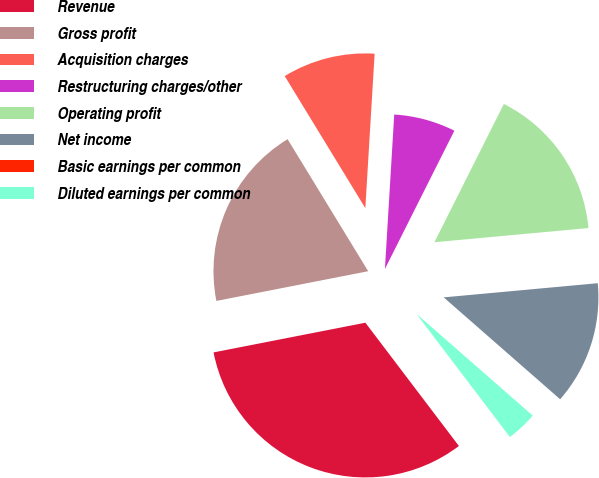Convert chart. <chart><loc_0><loc_0><loc_500><loc_500><pie_chart><fcel>Revenue � � � � � � � � � � �<fcel>Gross profit � � � � � � � � �<fcel>Acquisition charges � � � � �<fcel>Restructuring charges/other �<fcel>Operating profit� � � � � � �<fcel>Net income � � � � � � � � � �<fcel>Basic earnings per common<fcel>Diluted earnings per common<nl><fcel>32.25%<fcel>19.35%<fcel>9.68%<fcel>6.45%<fcel>16.13%<fcel>12.9%<fcel>0.0%<fcel>3.23%<nl></chart> 